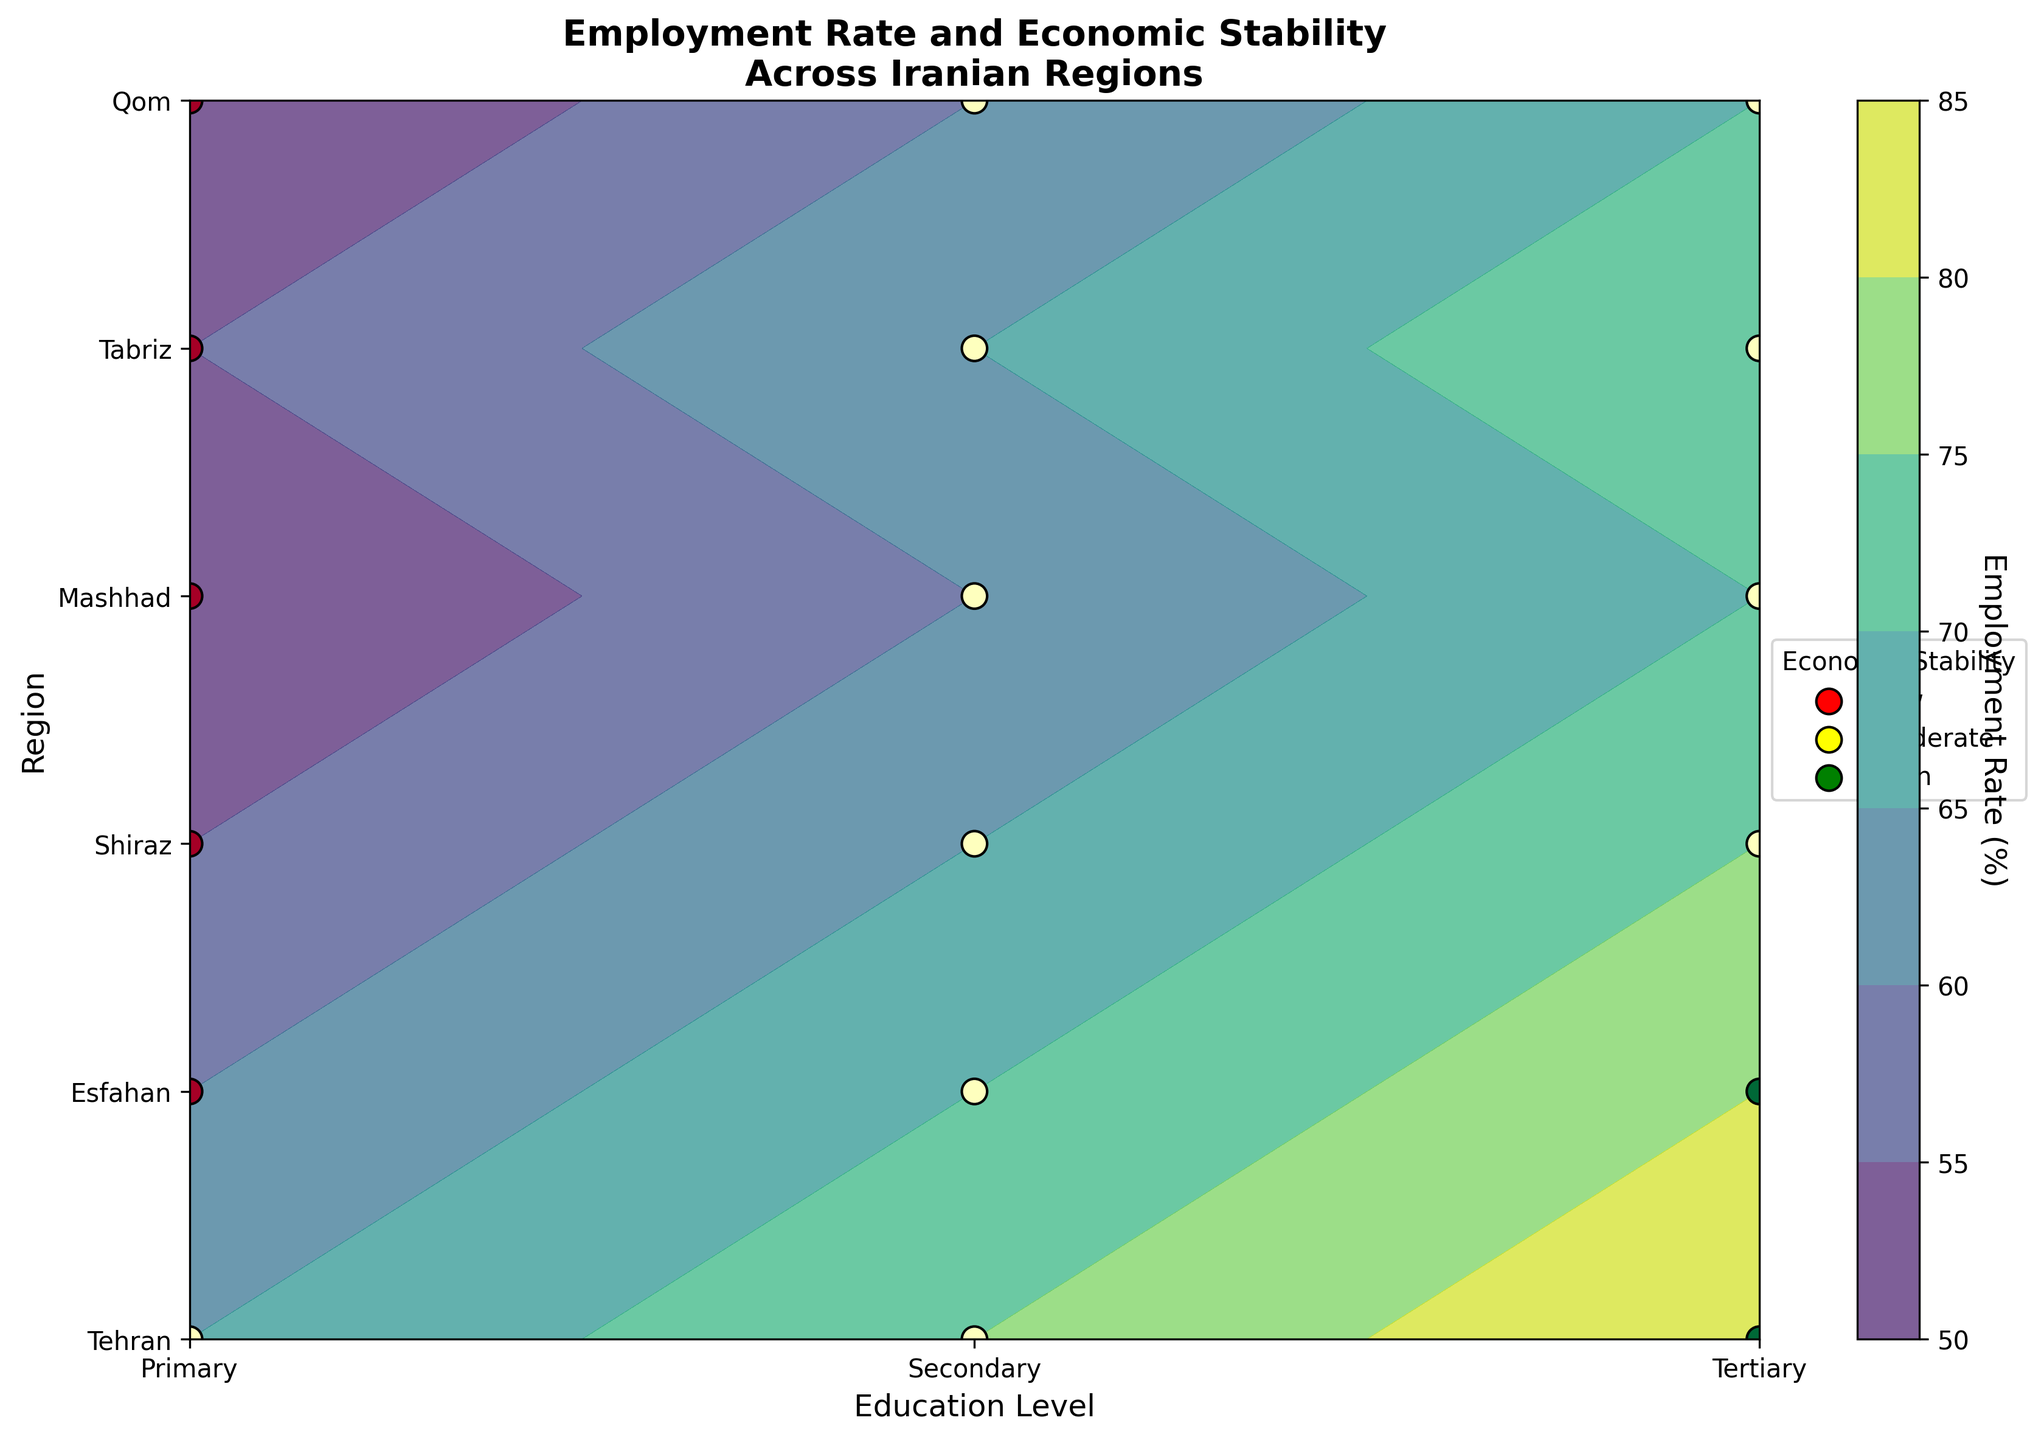What is the title of the figure? The title of the figure is usually positioned at the top of the chart, clearly indicating the main topic or data being represented. According to the code provided, the title of the figure is printed using 'ax.set_title'.
Answer: Employment Rate and Economic Stability Across Iranian Regions Which region has the highest employment rate for tertiary education? To find this, look at the contour plot for the section corresponding to the tertiary education level and identify which region's marker is at the highest employment rate level. Tertiary education is marked on the X-axis, and comparing the contours vertically across all regions will show the maximum value.
Answer: Tehran How does the economic stability of Shiraz compare across different education levels? To answer this, observe the color and position of the markers representing economic stability in Shiraz for primary, secondary, and tertiary education. Shiraz is marked on the Y-axis, and the different education levels are on the X-axis. The economic stability markers for primary, secondary, and tertiary education need to be checked for Shiraz.
Answer: Low for primary, Moderate for secondary and tertiary What is the general trend of employment rates as educational attainment increases in Tehran? Examine the contour lines or filled contours corresponding to Tehran for primary, secondary, and tertiary education levels, and note the values of employment rates for each educational level.
Answer: Increasing Which region has the lowest economic stability for tertiary education, and what does this imply about its employment rate? First, locate the tertiary education level section on the X-axis. Then, identify markers representing economic stability for all regions within the tertiary education level and find the one labeled as 'Low'. This will show the respective region and implications for employment rate.
Answer: No region; all have moderate or high How do the employment rates of Esfahan compare between primary and secondary education levels? Analyze the contour plot for Esfahan for both primary and secondary education levels, and then compare the numerical values of the employment rates for these two levels of education in the same region.
Answer: Primary: 60%; Secondary: 70% Is there a region where economic stability does not improve with higher educational levels? Examine each region's economic stability markers across primary, secondary, and tertiary educational levels, noticing if there's a region where economic stability remains the same regardless of education level.
Answer: Qom Which color on the plot represents high economic stability, and how does it help in interpreting the contour plot? The plot uses a color-coding scheme for economic stability, where different colors signify different stability levels. According to the legend, you can identify which color represents high stability and observe its occurrence on the plot to interpret regional economic information.
Answer: Green 